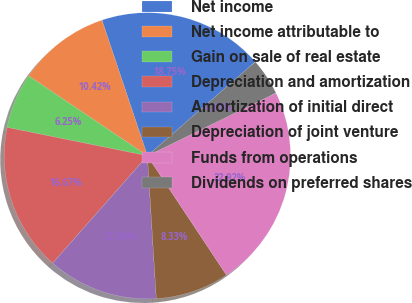<chart> <loc_0><loc_0><loc_500><loc_500><pie_chart><fcel>Net income<fcel>Net income attributable to<fcel>Gain on sale of real estate<fcel>Depreciation and amortization<fcel>Amortization of initial direct<fcel>Depreciation of joint venture<fcel>Funds from operations<fcel>Dividends on preferred shares<nl><fcel>18.75%<fcel>10.42%<fcel>6.25%<fcel>16.67%<fcel>12.5%<fcel>8.33%<fcel>22.92%<fcel>4.17%<nl></chart> 